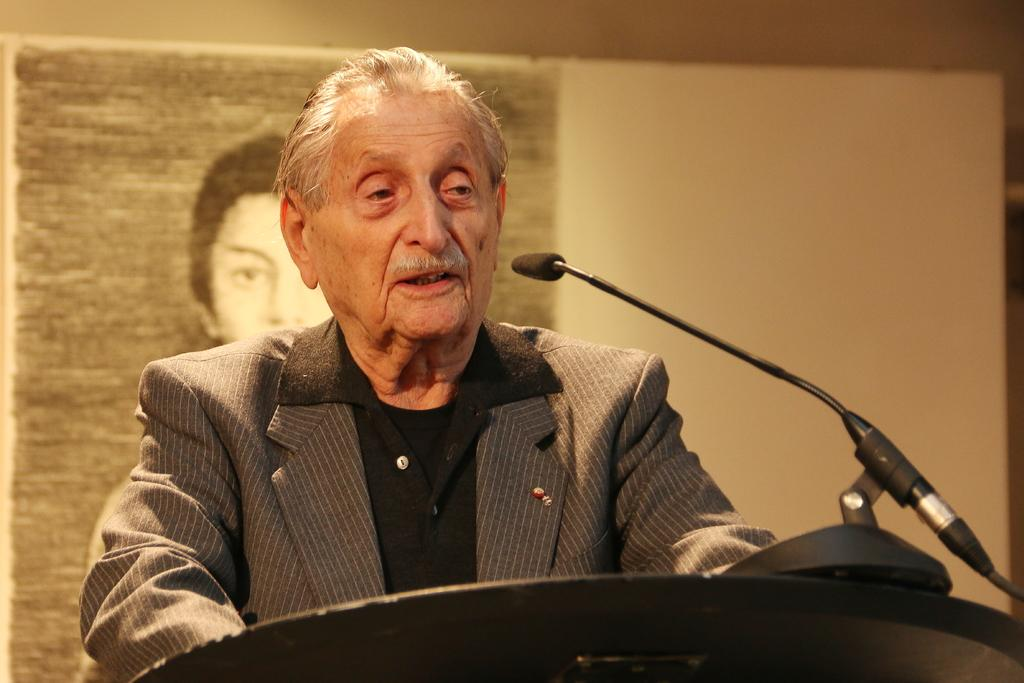What is the person in the image wearing? The person is wearing a suit. What objects are related to speaking or performing in the image? There is a microphone and a microphone stand in the image. How are the microphone and its stand positioned in relation to the person? The microphone and its stand are in front of the person. What type of image can be seen behind the person? There is a photo of a person in the image. What type of bun is being served at the amusement park in the image? There is no amusement park or bun present in the image. Is the person in the image wearing a vest? The provided facts do not mention a vest; the person is only described as wearing a suit. 